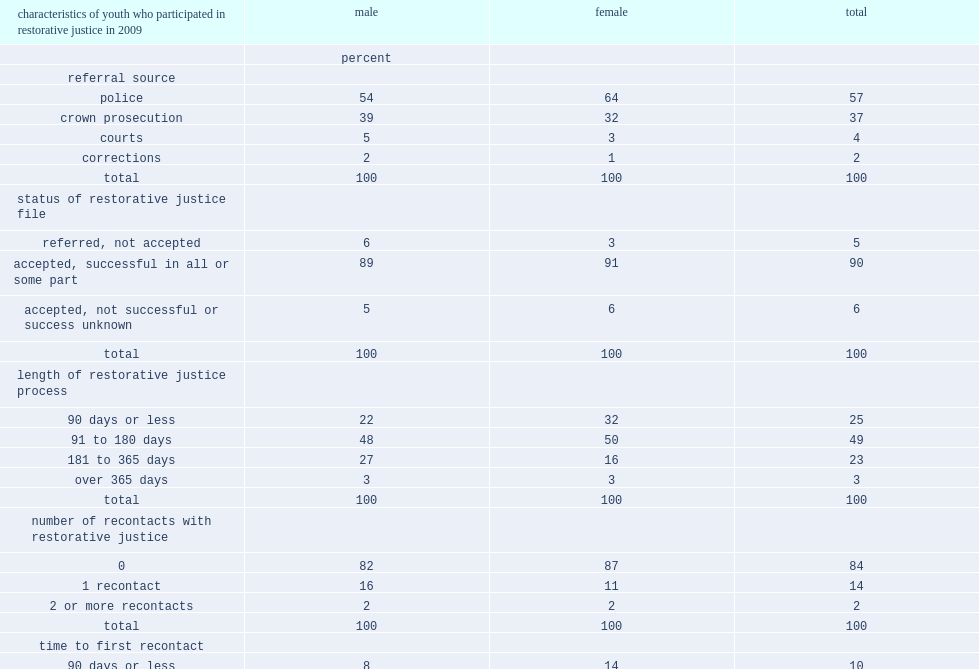What is the percentage of the referrals for youth to rj were from police (pre-charge)? 57.0. What is the percentage of referrals for youth to rj were by crown prosecution? 37.0. What is the percentage of referrals from courts or corrections? 6. Who were more likely to be referred by police? Female. Who were more likely to be referred by referred by prosecutors? Male. What is the percentage of cases took 90 days or less in the rj process? 25.0. What is the percentage of cases took three and six months in the rj process? 49.0. What is the percentage of cases took six months to a year in the rj process? 23.0. What is the percentage of cases took longer than one year in the rj process? 3.0. What is the percentage of the youth who participated in rj in nova scotia did not have any further contact as youth with rj in nova scotia? 84.0. What is the percentage of the youth who had at least one further contact with rj between 2009/2010 and 2014/2015? 16. Who is were more likely to have re-contact with rj? Male. What is the percentage of youth who had recontact with rj,the time between the two processes was over one year? 51.0. What is the percentage of offenders had re-contact when the first rj offence was violent? 21.0. What is the percentage of offenders had re-contact when the first rj offence was property crime? 15.0. What is the percentage of youth who had re-contact with rj of second processes or files was less serious? 35.0. What is the percentage of youth who had re-contact with rj of second processes or files was a similar level of seriousness? 23.0. What is the percentage of youth who had re-contact with rj of second processes or files was a more serious offence? 42.0. 